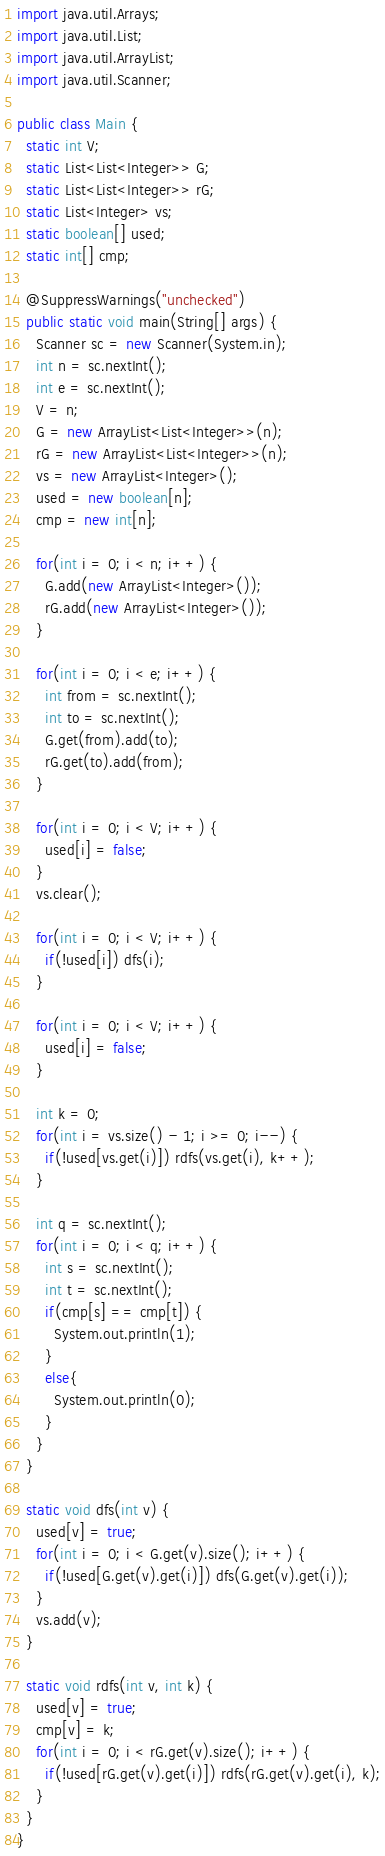<code> <loc_0><loc_0><loc_500><loc_500><_Java_>import java.util.Arrays;
import java.util.List;
import java.util.ArrayList;
import java.util.Scanner;

public class Main {
  static int V;
  static List<List<Integer>> G;
  static List<List<Integer>> rG;
  static List<Integer> vs;
  static boolean[] used;
  static int[] cmp;
 
  @SuppressWarnings("unchecked")
  public static void main(String[] args) {
    Scanner sc = new Scanner(System.in);
    int n = sc.nextInt();
    int e = sc.nextInt();
    V = n;
    G = new ArrayList<List<Integer>>(n);
    rG = new ArrayList<List<Integer>>(n);
    vs = new ArrayList<Integer>();
    used = new boolean[n];
    cmp = new int[n];

    for(int i = 0; i < n; i++) {
      G.add(new ArrayList<Integer>());
      rG.add(new ArrayList<Integer>());
    }

    for(int i = 0; i < e; i++) {
      int from = sc.nextInt();
      int to = sc.nextInt();
      G.get(from).add(to);
      rG.get(to).add(from);
    }

    for(int i = 0; i < V; i++) {
      used[i] = false;
    }
    vs.clear();

    for(int i = 0; i < V; i++) {
      if(!used[i]) dfs(i);
    }

    for(int i = 0; i < V; i++) {
      used[i] = false;
    }

    int k = 0;  
    for(int i = vs.size() - 1; i >= 0; i--) {
      if(!used[vs.get(i)]) rdfs(vs.get(i), k++);
    }

    int q = sc.nextInt();
    for(int i = 0; i < q; i++) {
      int s = sc.nextInt();
      int t = sc.nextInt();
      if(cmp[s] == cmp[t]) {
        System.out.println(1);
      }
      else{
        System.out.println(0);
      }
    }
  }

  static void dfs(int v) {
    used[v] = true; 
    for(int i = 0; i < G.get(v).size(); i++) {
      if(!used[G.get(v).get(i)]) dfs(G.get(v).get(i));
    }
    vs.add(v);
  }
  
  static void rdfs(int v, int k) {
    used[v] = true;
    cmp[v] = k;
    for(int i = 0; i < rG.get(v).size(); i++) {
      if(!used[rG.get(v).get(i)]) rdfs(rG.get(v).get(i), k);
    }
  }
}</code> 